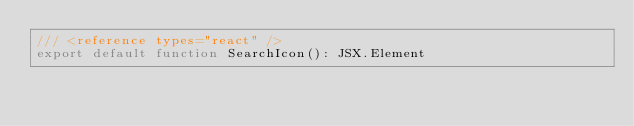Convert code to text. <code><loc_0><loc_0><loc_500><loc_500><_TypeScript_>/// <reference types="react" />
export default function SearchIcon(): JSX.Element
</code> 